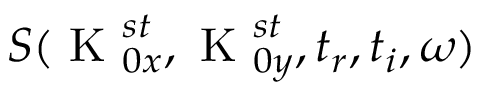Convert formula to latex. <formula><loc_0><loc_0><loc_500><loc_500>S ( K _ { 0 x } ^ { s t } , K _ { 0 y } ^ { s t } , t _ { r } , t _ { i } , \omega )</formula> 